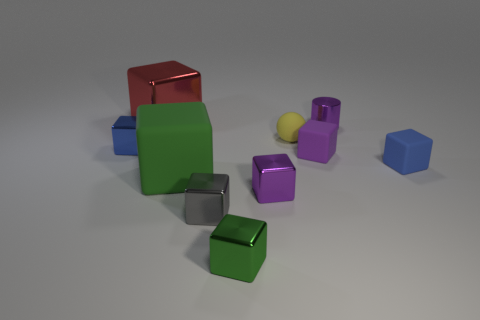Subtract 5 blocks. How many blocks are left? 3 Subtract all blue cubes. How many cubes are left? 6 Subtract all large red cubes. How many cubes are left? 7 Subtract all blue cubes. Subtract all purple cylinders. How many cubes are left? 6 Subtract all cubes. How many objects are left? 2 Subtract 0 gray cylinders. How many objects are left? 10 Subtract all large matte objects. Subtract all tiny red shiny cylinders. How many objects are left? 9 Add 8 green matte cubes. How many green matte cubes are left? 9 Add 6 small cyan cylinders. How many small cyan cylinders exist? 6 